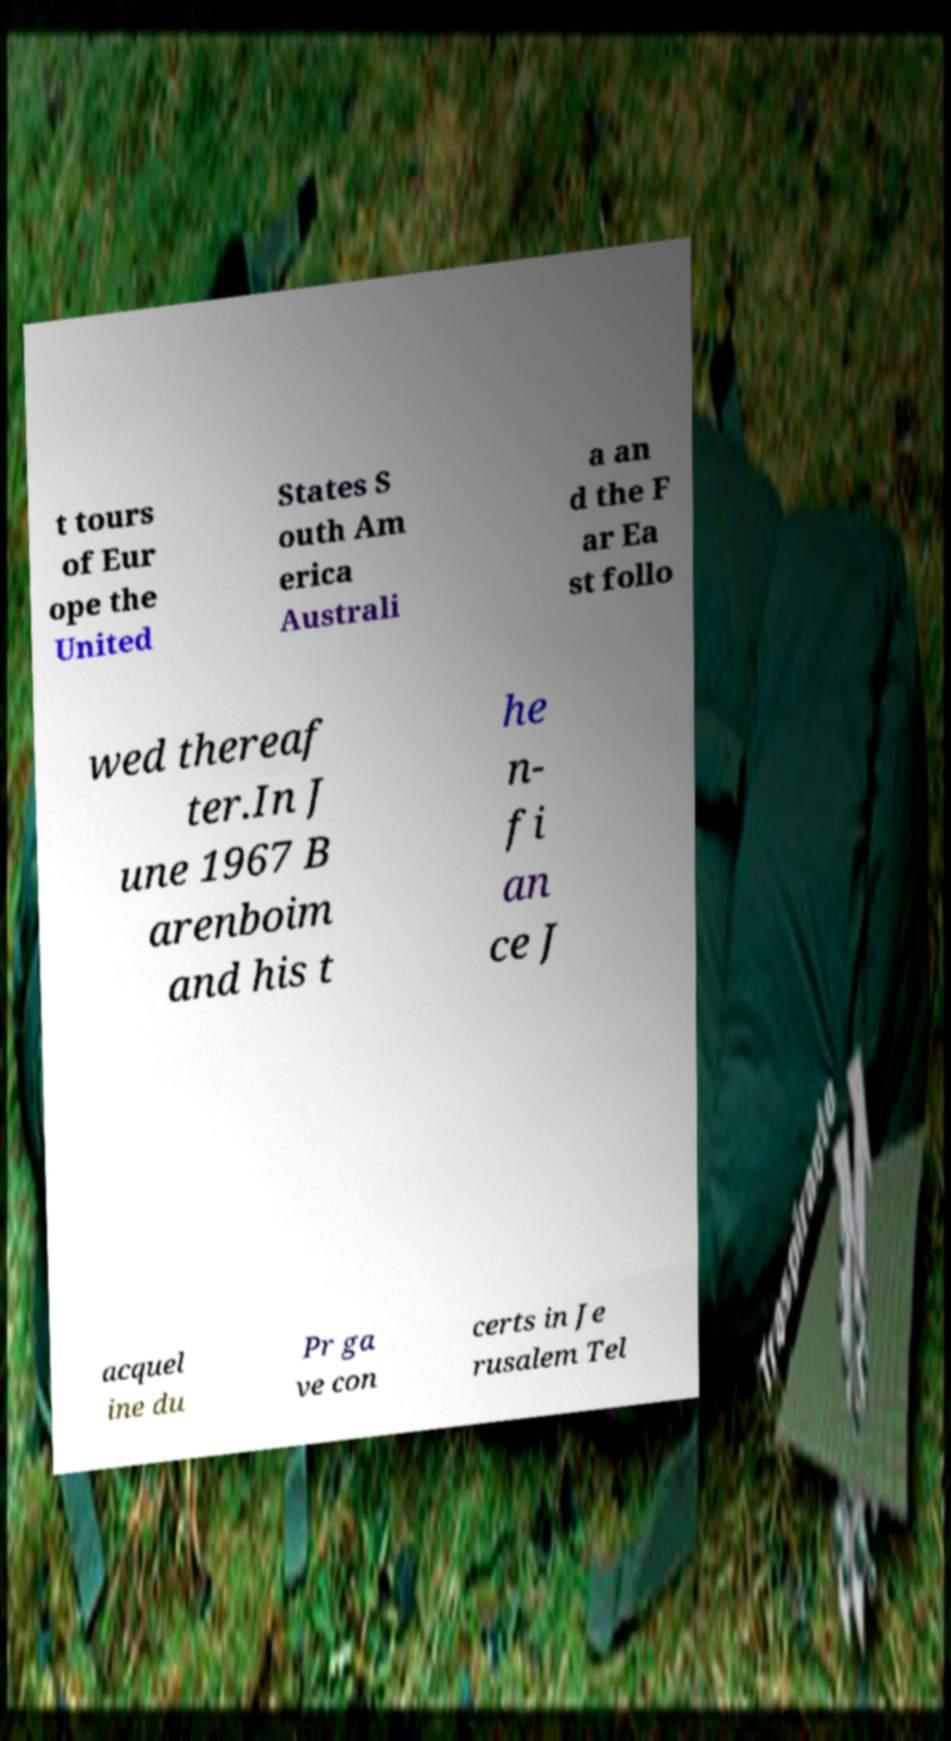Please read and relay the text visible in this image. What does it say? t tours of Eur ope the United States S outh Am erica Australi a an d the F ar Ea st follo wed thereaf ter.In J une 1967 B arenboim and his t he n- fi an ce J acquel ine du Pr ga ve con certs in Je rusalem Tel 